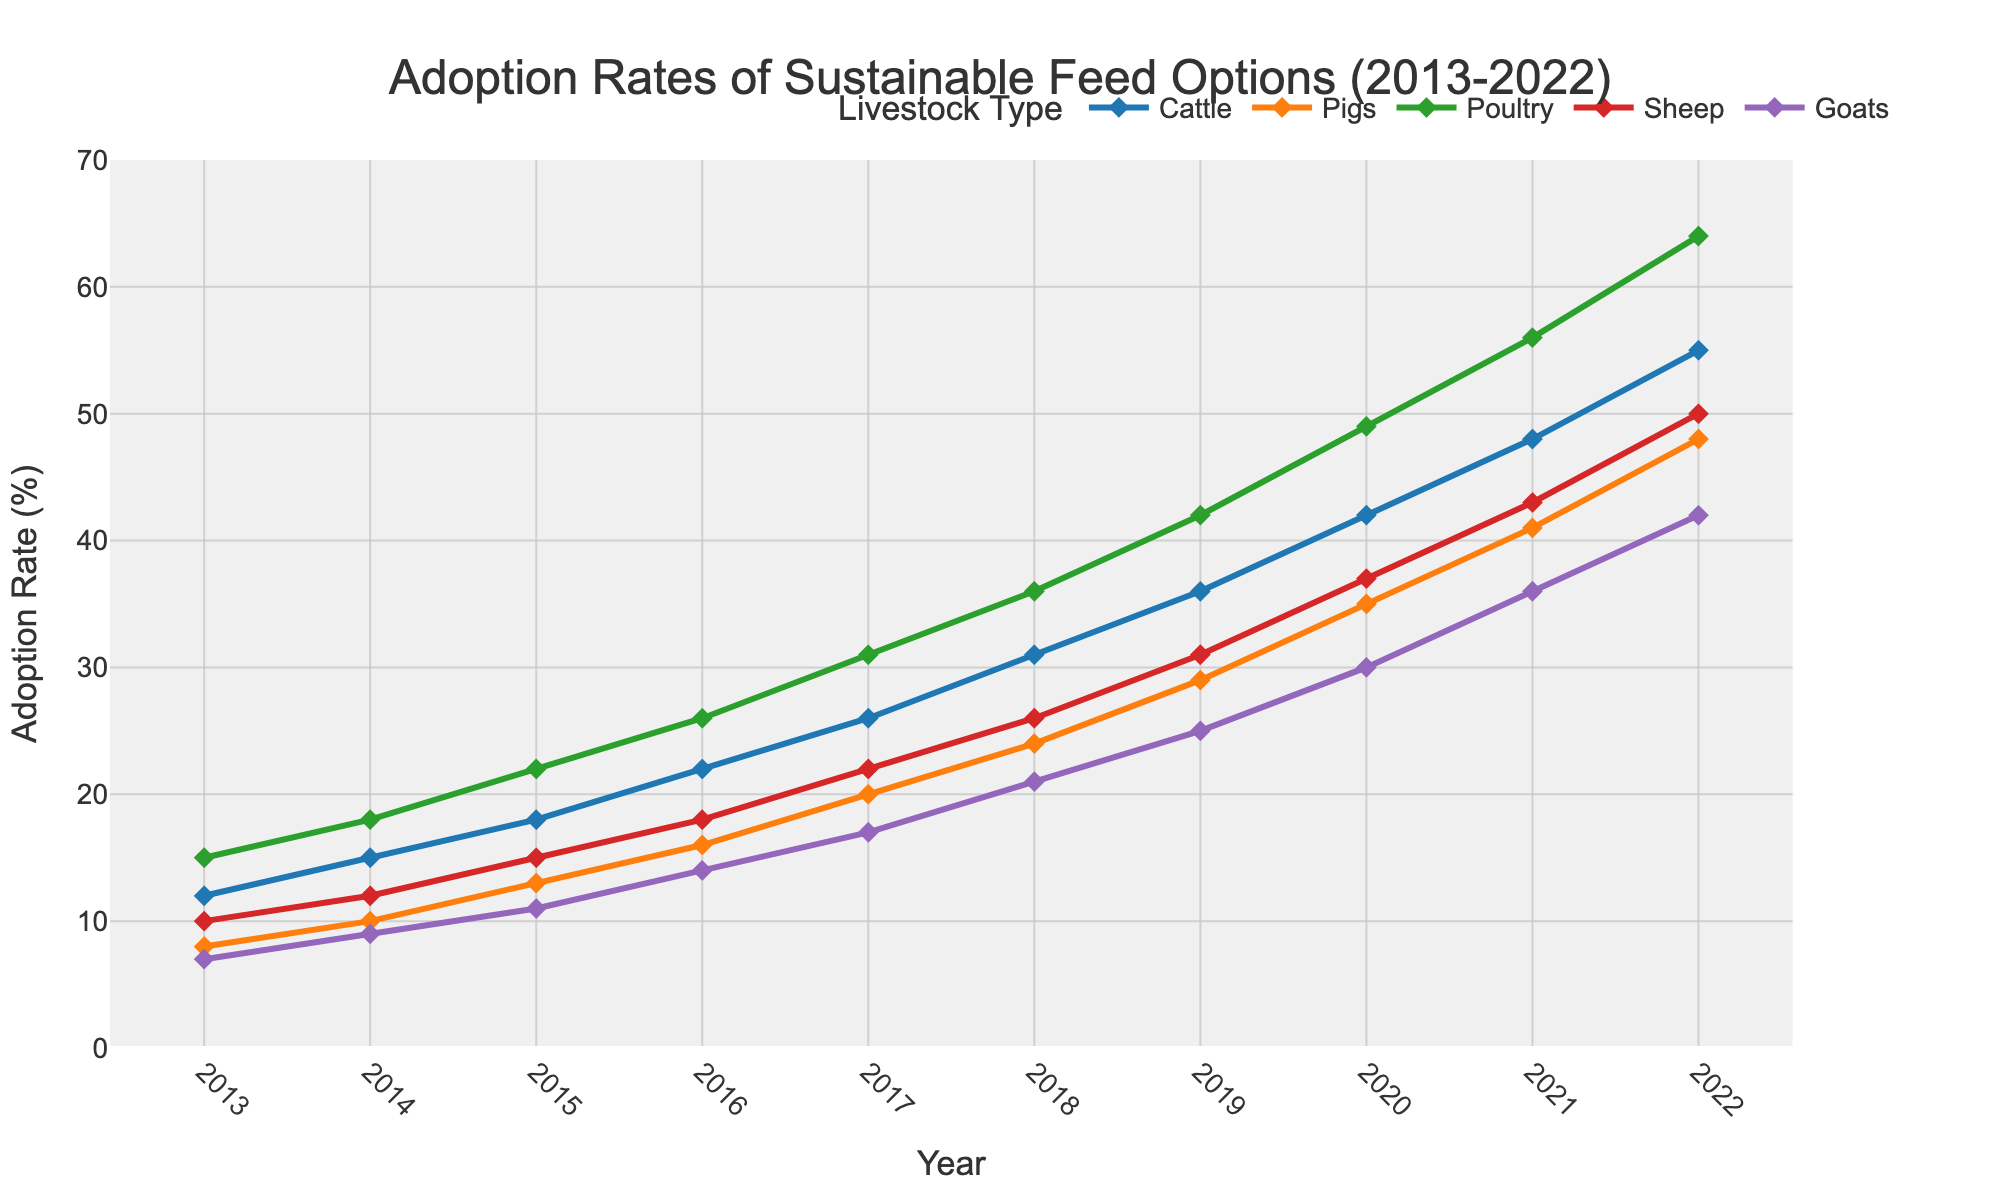what is the adoption rate for sustainable feed in poultry in the year 2017? The figure shows adoption rates for different livestock types each year. For poultry in 2017, follow the poultry line to the year 2017 position on the x-axis and read the corresponding y-axis value.
Answer: 31% which livestock type saw the highest adoption rate in 2022? To determine this, observe the adoption rates for all livestock types in 2022 and compare their values. The livestock type with the highest number corresponds to the highest adoption rate.
Answer: Cattle in which year did goats surpass a 20% adoption rate? Follow the trend line for goats. Identify the first year where the adoption rate exceeds 20% by checking the y-values
Answer: 2018 how much did the adoption rate for pigs increase from 2013 to 2022? Subtract the adoption rate for pigs in 2013 from that in 2022. For 2013, the rate is 8%, and for 2022, it is 48%. 48% - 8% = 40%
Answer: 40% what is the combined adoption rate of cattle and sheep in 2020? Check the chart for the adoption rates of cattle and sheep in 2020. Add the values: Cattle (42%) + Sheep (37%). The sum is 42 + 37 = 79%.
Answer: 79% In which year did the adoption rate for sheep equal the adoption rate for goats? Examine the trend lines for both sheep and goats to find the year when they cross or have the same value.
Answer: 2018 between 2016 and 2020, how did the adoption rate for poultry perform compared to pigs, in terms of change in rate? First, find the adoption rates for poultry and pigs in 2016 and 2020. Calculate the differences. For poultry: 49% (2020) - 26% (2016) = 23%. For pigs: 35% (2020) - 16% (2016) = 19%. Compare the changes.
Answer: Poultry increased by 23%, pigs by 19% which livestock type had its steepest rise in adoption rate between 2015 and 2017, based on the slope of the lines? Observe the trend lines for all livestock types between 2015 and 2017 and determine which line has the steepest incline. This corresponds to the livestock type with the highest increase in rate over that period.
Answer: Cattle what was the average adoption rate of sustainable feed across all livestock types in 2015? Add the adoption rates for all livestock types in 2015 and divide by the number of livestock types (5). Rates: Cattle (18%), Pigs (13%), Poultry (22%), Sheep (15%), Goats (11%). Sum: 18+13+22+15+11 = 79. Average = 79/5 = 15.8%.
Answer: 15.8% compare the adoption rate of sheep and poultry in 2019. Which one is higher and by how much? Note the adoption rates for sheep (31%) and poultry (42%) in 2019. Subtract the rate for sheep from that for poultry. 42% - 31% = 11%.
Answer: Poultry, by 11% 